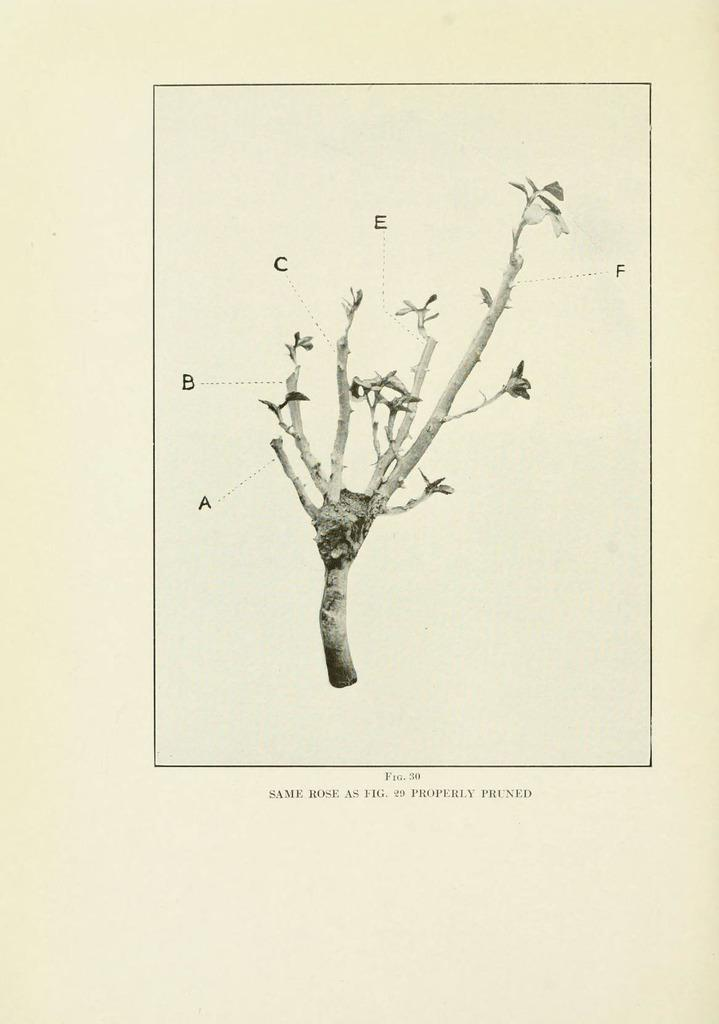What is present in the image that is made of paper? There is a paper in the image. What is the color of the paper? The paper is cream in color. What is depicted on the paper? There is a picture of a plant on the paper. What else can be seen on the paper? There is writing on the paper. How does the digestion process of the plant on the paper work? The image on the paper is a static representation of a plant and does not depict any biological processes, such as digestion. 